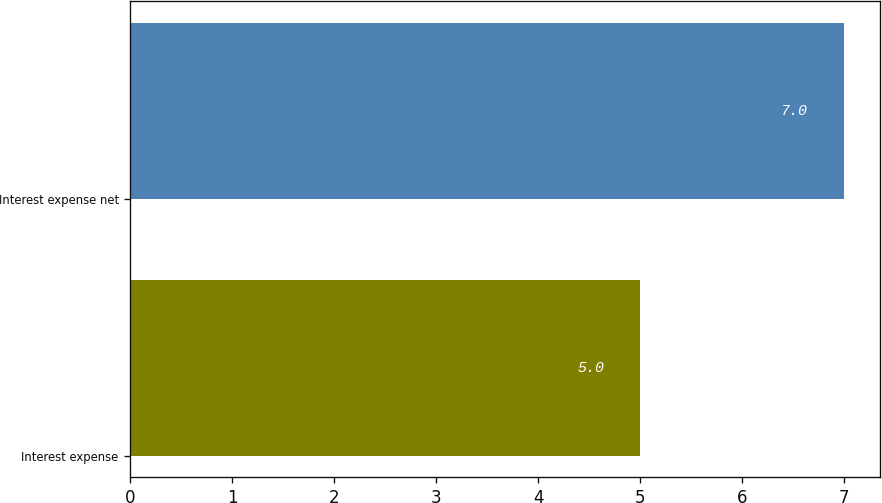Convert chart to OTSL. <chart><loc_0><loc_0><loc_500><loc_500><bar_chart><fcel>Interest expense<fcel>Interest expense net<nl><fcel>5<fcel>7<nl></chart> 